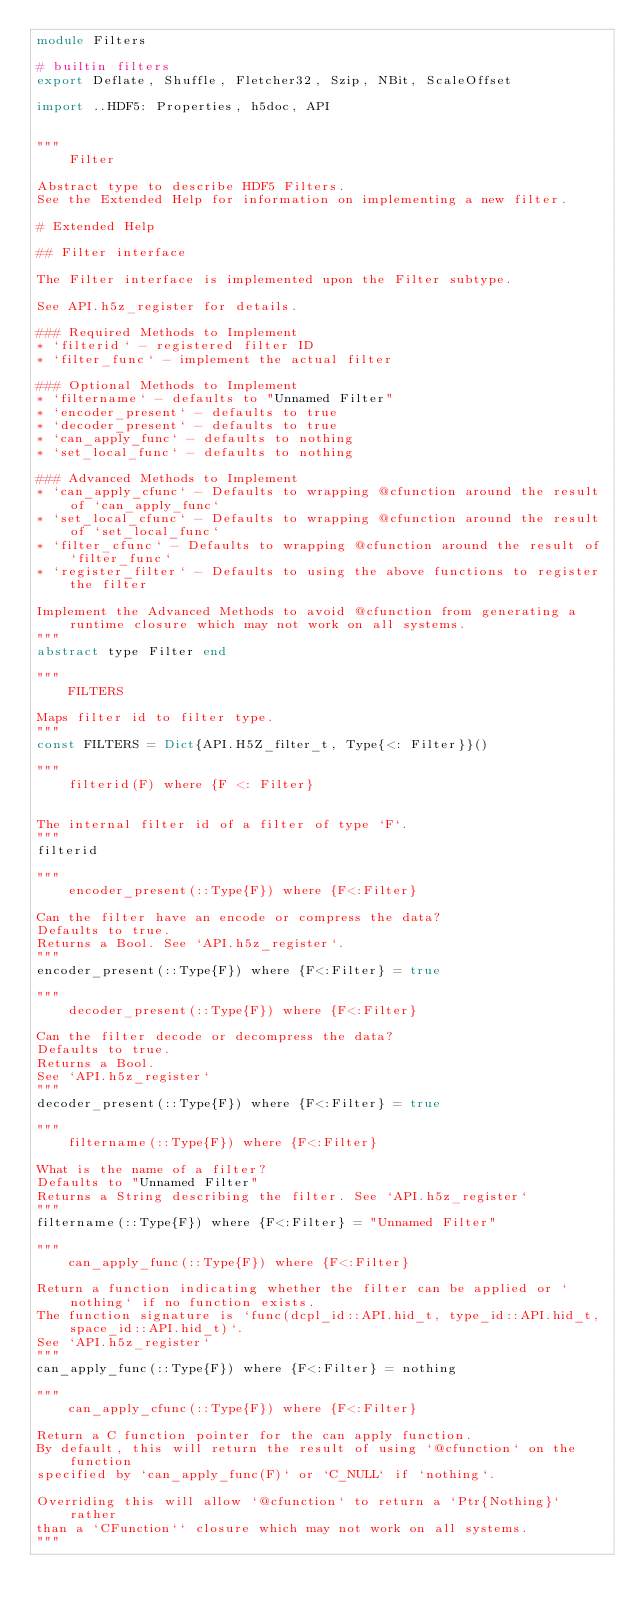<code> <loc_0><loc_0><loc_500><loc_500><_Julia_>module Filters

# builtin filters
export Deflate, Shuffle, Fletcher32, Szip, NBit, ScaleOffset

import ..HDF5: Properties, h5doc, API


"""
    Filter

Abstract type to describe HDF5 Filters.
See the Extended Help for information on implementing a new filter.

# Extended Help

## Filter interface

The Filter interface is implemented upon the Filter subtype.

See API.h5z_register for details.

### Required Methods to Implement
* `filterid` - registered filter ID
* `filter_func` - implement the actual filter

### Optional Methods to Implement
* `filtername` - defaults to "Unnamed Filter"
* `encoder_present` - defaults to true
* `decoder_present` - defaults to true
* `can_apply_func` - defaults to nothing
* `set_local_func` - defaults to nothing

### Advanced Methods to Implement
* `can_apply_cfunc` - Defaults to wrapping @cfunction around the result of `can_apply_func`
* `set_local_cfunc` - Defaults to wrapping @cfunction around the result of `set_local_func`
* `filter_cfunc` - Defaults to wrapping @cfunction around the result of `filter_func`
* `register_filter` - Defaults to using the above functions to register the filter

Implement the Advanced Methods to avoid @cfunction from generating a runtime closure which may not work on all systems.
"""
abstract type Filter end

"""
    FILTERS

Maps filter id to filter type.
"""
const FILTERS = Dict{API.H5Z_filter_t, Type{<: Filter}}()

"""
    filterid(F) where {F <: Filter}


The internal filter id of a filter of type `F`.
"""
filterid

"""
    encoder_present(::Type{F}) where {F<:Filter}

Can the filter have an encode or compress the data?
Defaults to true.
Returns a Bool. See `API.h5z_register`.
"""
encoder_present(::Type{F}) where {F<:Filter} = true

"""
    decoder_present(::Type{F}) where {F<:Filter}

Can the filter decode or decompress the data?
Defaults to true.
Returns a Bool.
See `API.h5z_register`
"""
decoder_present(::Type{F}) where {F<:Filter} = true

"""
    filtername(::Type{F}) where {F<:Filter}

What is the name of a filter?
Defaults to "Unnamed Filter"
Returns a String describing the filter. See `API.h5z_register`
"""
filtername(::Type{F}) where {F<:Filter} = "Unnamed Filter"

"""
    can_apply_func(::Type{F}) where {F<:Filter}

Return a function indicating whether the filter can be applied or `nothing` if no function exists.
The function signature is `func(dcpl_id::API.hid_t, type_id::API.hid_t, space_id::API.hid_t)`.
See `API.h5z_register`
"""
can_apply_func(::Type{F}) where {F<:Filter} = nothing

"""
    can_apply_cfunc(::Type{F}) where {F<:Filter}

Return a C function pointer for the can apply function.
By default, this will return the result of using `@cfunction` on the function
specified by `can_apply_func(F)` or `C_NULL` if `nothing`.

Overriding this will allow `@cfunction` to return a `Ptr{Nothing}` rather
than a `CFunction`` closure which may not work on all systems.
"""</code> 